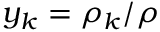<formula> <loc_0><loc_0><loc_500><loc_500>y _ { k } = \rho _ { k } / \rho</formula> 